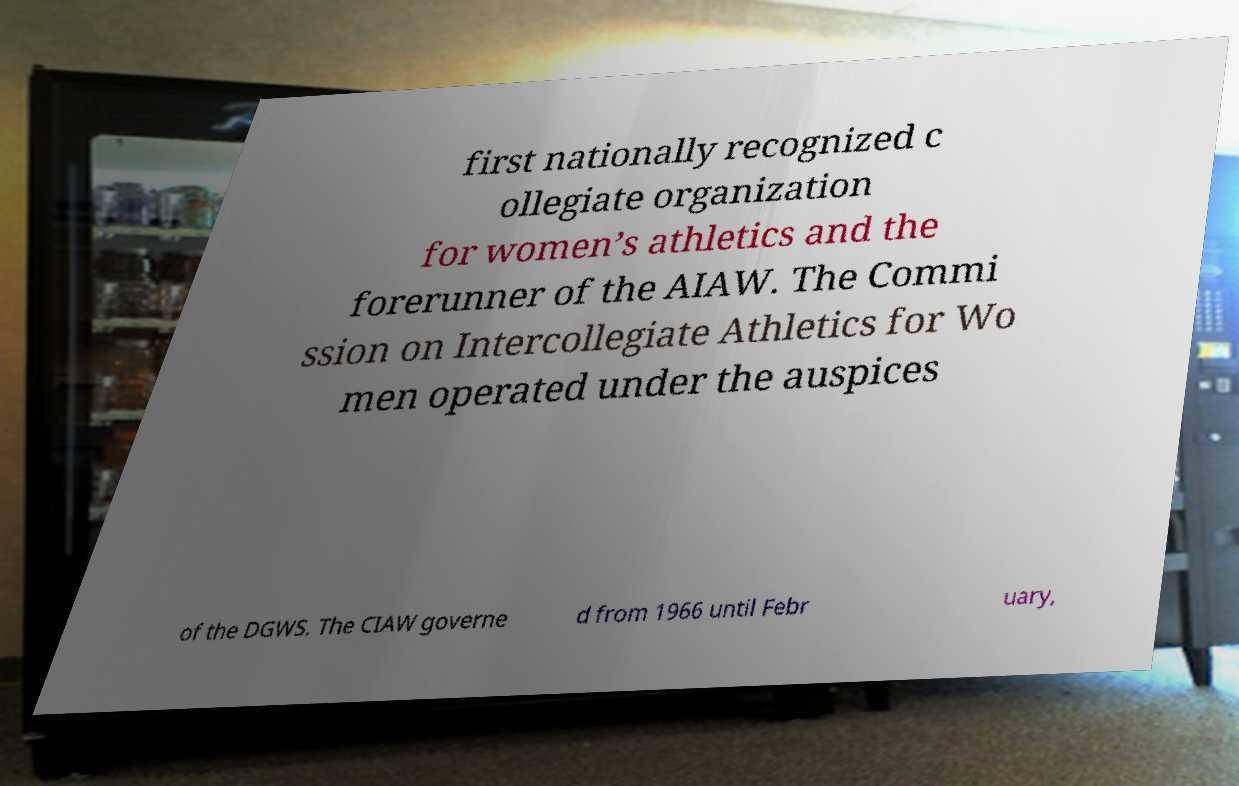Can you read and provide the text displayed in the image?This photo seems to have some interesting text. Can you extract and type it out for me? first nationally recognized c ollegiate organization for women’s athletics and the forerunner of the AIAW. The Commi ssion on Intercollegiate Athletics for Wo men operated under the auspices of the DGWS. The CIAW governe d from 1966 until Febr uary, 